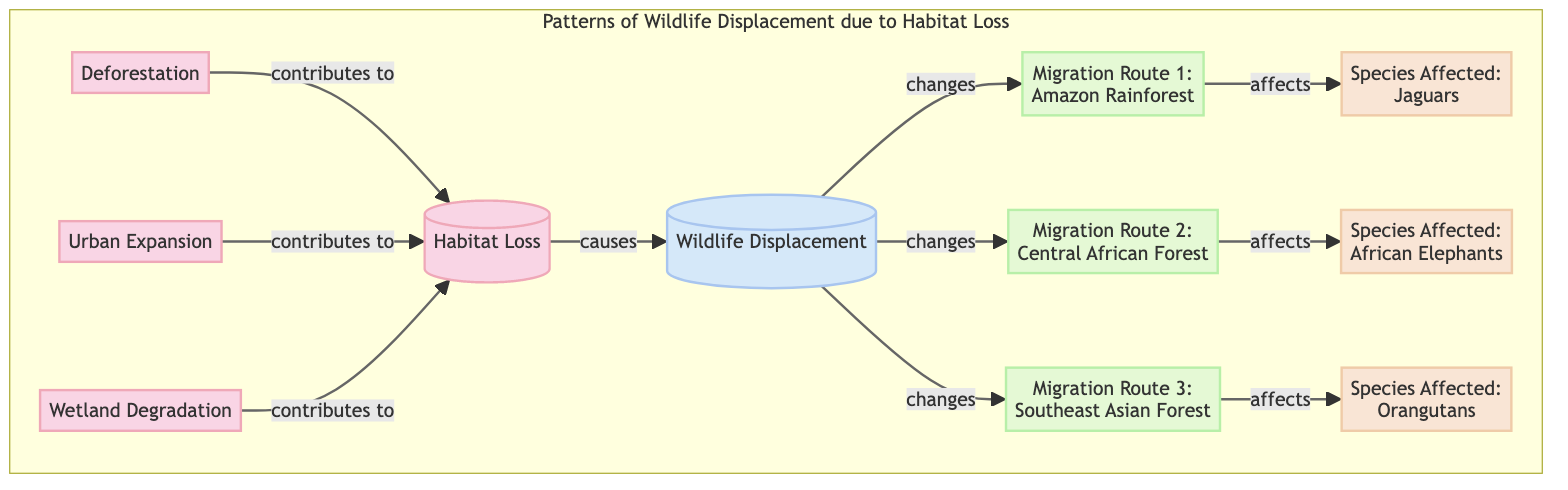What causes wildlife displacement? The diagram shows that wildlife displacement is caused by habitat loss, which is indicated by the arrow pointing from "Habitat Loss" to "Wildlife Displacement."
Answer: Habitat Loss How many migration routes are shown in the diagram? By counting the nodes labeled as "Migration Route" in the diagram, there are three distinct migration routes listed.
Answer: 3 Which habitat loss type contributes to wildlife displacement? The diagram specifies that habitat loss types, such as deforestation, urban expansion, and wetland degradation, all contribute to the primary cause of wildlife displacement.
Answer: Deforestation, Urban Expansion, Wetland Degradation Which species is affected by Migration Route 1? Looking at the diagram, "Jaguars" is the species listed as being affected by Migration Route 1, which is the Amazon Rainforest.
Answer: Jaguars What is the relationship between urban expansion and habitat loss? The flowchart indicates that urban expansion contributes to habitat loss, supported by the arrow pointing from "Urban Expansion" to "Habitat Loss."
Answer: Contributes to Which migration route affects African Elephants? The diagram specifically states that "Migration Route 2: Central African Forest" affects African Elephants, as indicated in the connected nodes.
Answer: Migration Route 2: Central African Forest Which species is associated with Migration Route 3? By examining the information in the diagram, "Orangutans" are explicitly mentioned as being affected by Migration Route 3.
Answer: Orangutans What type of degradation affects wildlife migration? The diagram points out that wetland degradation is a type of habitat loss that has implications for wildlife displacement and migration routes.
Answer: Wetland Degradation How are the migration routes visually categorized in the diagram? The migration routes in the diagram are visually categorized with a specific style that differentiates them as a unique class, identified by the green fill color.
Answer: Green fill color 